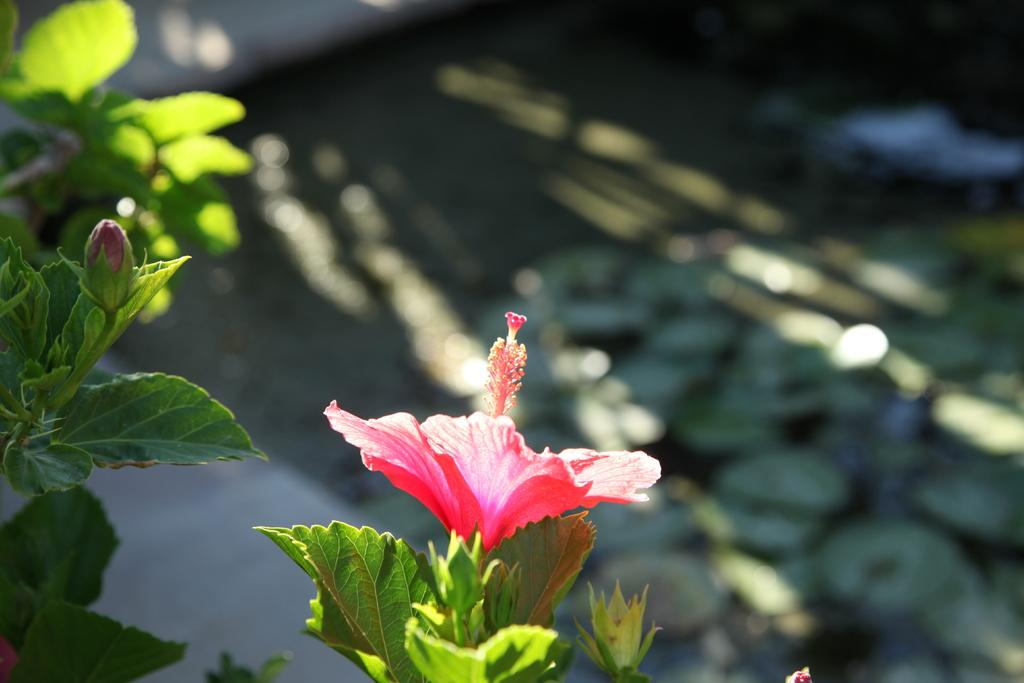What type of plants can be seen in the image? There are plants with flowers in the image. What color is the flower on the plant? The flower is red in color. Can you describe any other stage of the flower's growth in the image? Yes, there is a flower bud visible in the image. What can be said about the plants in the background of the image? Some plants in the background are not clearly visible. How many cherries are hanging from the flower in the image? There are no cherries present in the image; it features plants with red flowers. Can you describe the behavior of the sheep in the image? There are no sheep present in the image. 